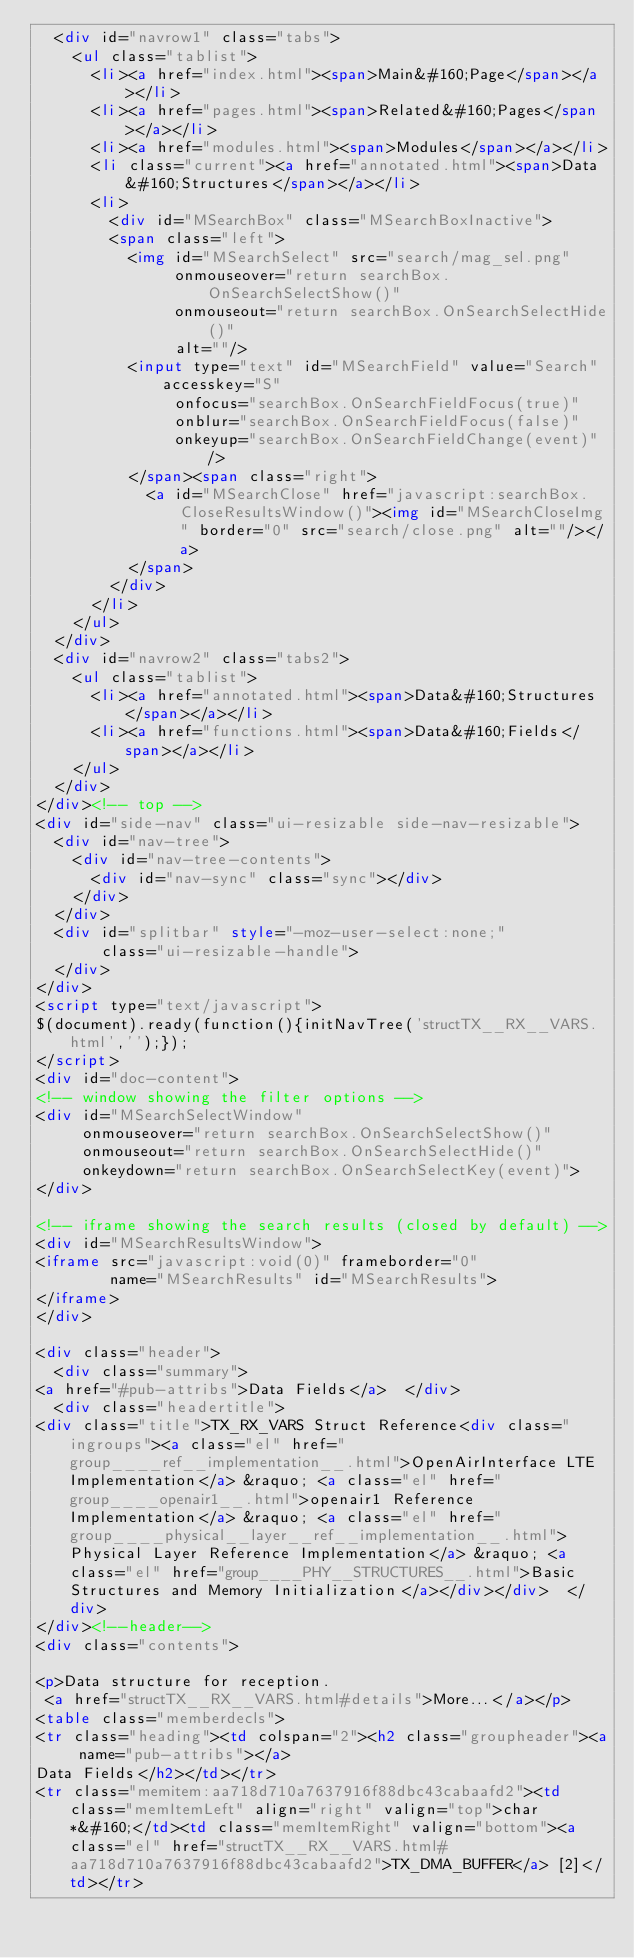Convert code to text. <code><loc_0><loc_0><loc_500><loc_500><_HTML_>  <div id="navrow1" class="tabs">
    <ul class="tablist">
      <li><a href="index.html"><span>Main&#160;Page</span></a></li>
      <li><a href="pages.html"><span>Related&#160;Pages</span></a></li>
      <li><a href="modules.html"><span>Modules</span></a></li>
      <li class="current"><a href="annotated.html"><span>Data&#160;Structures</span></a></li>
      <li>
        <div id="MSearchBox" class="MSearchBoxInactive">
        <span class="left">
          <img id="MSearchSelect" src="search/mag_sel.png"
               onmouseover="return searchBox.OnSearchSelectShow()"
               onmouseout="return searchBox.OnSearchSelectHide()"
               alt=""/>
          <input type="text" id="MSearchField" value="Search" accesskey="S"
               onfocus="searchBox.OnSearchFieldFocus(true)" 
               onblur="searchBox.OnSearchFieldFocus(false)" 
               onkeyup="searchBox.OnSearchFieldChange(event)"/>
          </span><span class="right">
            <a id="MSearchClose" href="javascript:searchBox.CloseResultsWindow()"><img id="MSearchCloseImg" border="0" src="search/close.png" alt=""/></a>
          </span>
        </div>
      </li>
    </ul>
  </div>
  <div id="navrow2" class="tabs2">
    <ul class="tablist">
      <li><a href="annotated.html"><span>Data&#160;Structures</span></a></li>
      <li><a href="functions.html"><span>Data&#160;Fields</span></a></li>
    </ul>
  </div>
</div><!-- top -->
<div id="side-nav" class="ui-resizable side-nav-resizable">
  <div id="nav-tree">
    <div id="nav-tree-contents">
      <div id="nav-sync" class="sync"></div>
    </div>
  </div>
  <div id="splitbar" style="-moz-user-select:none;" 
       class="ui-resizable-handle">
  </div>
</div>
<script type="text/javascript">
$(document).ready(function(){initNavTree('structTX__RX__VARS.html','');});
</script>
<div id="doc-content">
<!-- window showing the filter options -->
<div id="MSearchSelectWindow"
     onmouseover="return searchBox.OnSearchSelectShow()"
     onmouseout="return searchBox.OnSearchSelectHide()"
     onkeydown="return searchBox.OnSearchSelectKey(event)">
</div>

<!-- iframe showing the search results (closed by default) -->
<div id="MSearchResultsWindow">
<iframe src="javascript:void(0)" frameborder="0" 
        name="MSearchResults" id="MSearchResults">
</iframe>
</div>

<div class="header">
  <div class="summary">
<a href="#pub-attribs">Data Fields</a>  </div>
  <div class="headertitle">
<div class="title">TX_RX_VARS Struct Reference<div class="ingroups"><a class="el" href="group____ref__implementation__.html">OpenAirInterface LTE Implementation</a> &raquo; <a class="el" href="group____openair1__.html">openair1 Reference Implementation</a> &raquo; <a class="el" href="group____physical__layer__ref__implementation__.html">Physical Layer Reference Implementation</a> &raquo; <a class="el" href="group____PHY__STRUCTURES__.html">Basic Structures and Memory Initialization</a></div></div>  </div>
</div><!--header-->
<div class="contents">

<p>Data structure for reception.  
 <a href="structTX__RX__VARS.html#details">More...</a></p>
<table class="memberdecls">
<tr class="heading"><td colspan="2"><h2 class="groupheader"><a name="pub-attribs"></a>
Data Fields</h2></td></tr>
<tr class="memitem:aa718d710a7637916f88dbc43cabaafd2"><td class="memItemLeft" align="right" valign="top">char *&#160;</td><td class="memItemRight" valign="bottom"><a class="el" href="structTX__RX__VARS.html#aa718d710a7637916f88dbc43cabaafd2">TX_DMA_BUFFER</a> [2]</td></tr></code> 